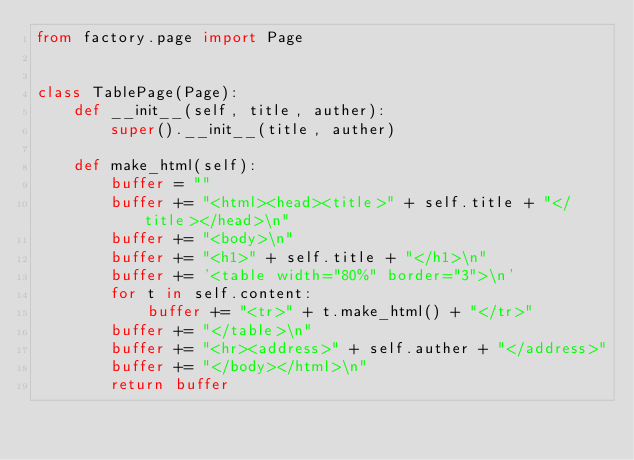Convert code to text. <code><loc_0><loc_0><loc_500><loc_500><_Python_>from factory.page import Page


class TablePage(Page):
    def __init__(self, title, auther):
        super().__init__(title, auther)

    def make_html(self):
        buffer = ""
        buffer += "<html><head><title>" + self.title + "</title></head>\n"
        buffer += "<body>\n"
        buffer += "<h1>" + self.title + "</h1>\n"
        buffer += '<table width="80%" border="3">\n'
        for t in self.content:
            buffer += "<tr>" + t.make_html() + "</tr>"
        buffer += "</table>\n"
        buffer += "<hr><address>" + self.auther + "</address>"
        buffer += "</body></html>\n"
        return buffer
</code> 